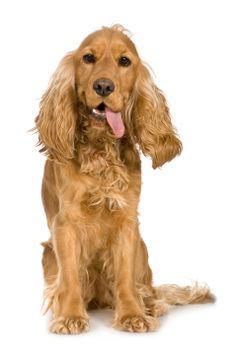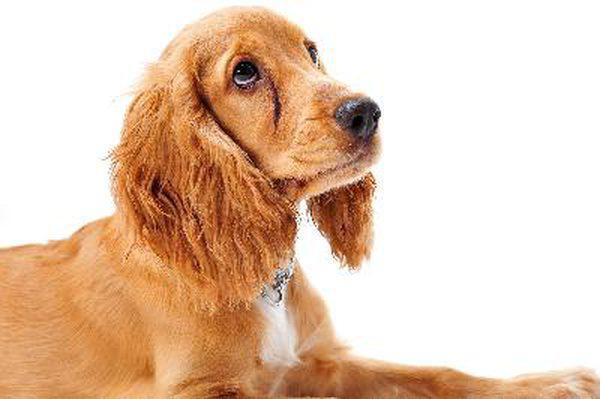The first image is the image on the left, the second image is the image on the right. Examine the images to the left and right. Is the description "A single dog tongue can be seen in the image on the left" accurate? Answer yes or no. Yes. The first image is the image on the left, the second image is the image on the right. Evaluate the accuracy of this statement regarding the images: "There is one dog with its tongue out.". Is it true? Answer yes or no. Yes. 